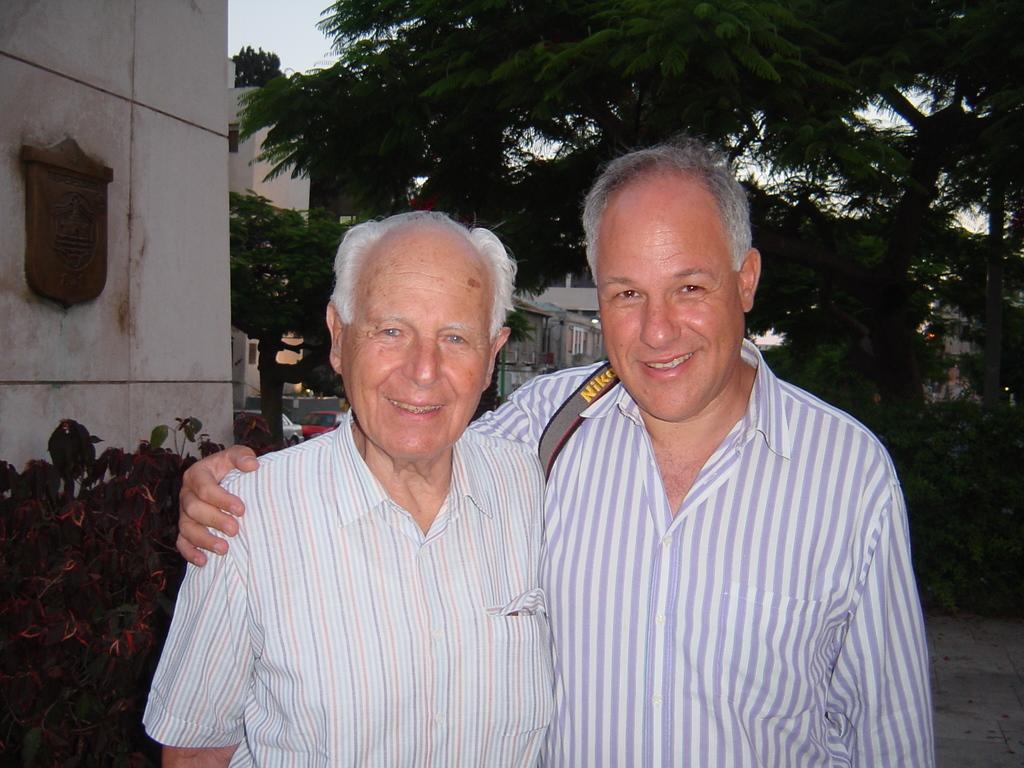Who made this mans strap on his arm?
Provide a succinct answer. Nikon. 